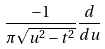<formula> <loc_0><loc_0><loc_500><loc_500>\frac { - 1 } { \pi \sqrt { u ^ { 2 } - t ^ { 2 } } } \frac { d } { d u }</formula> 